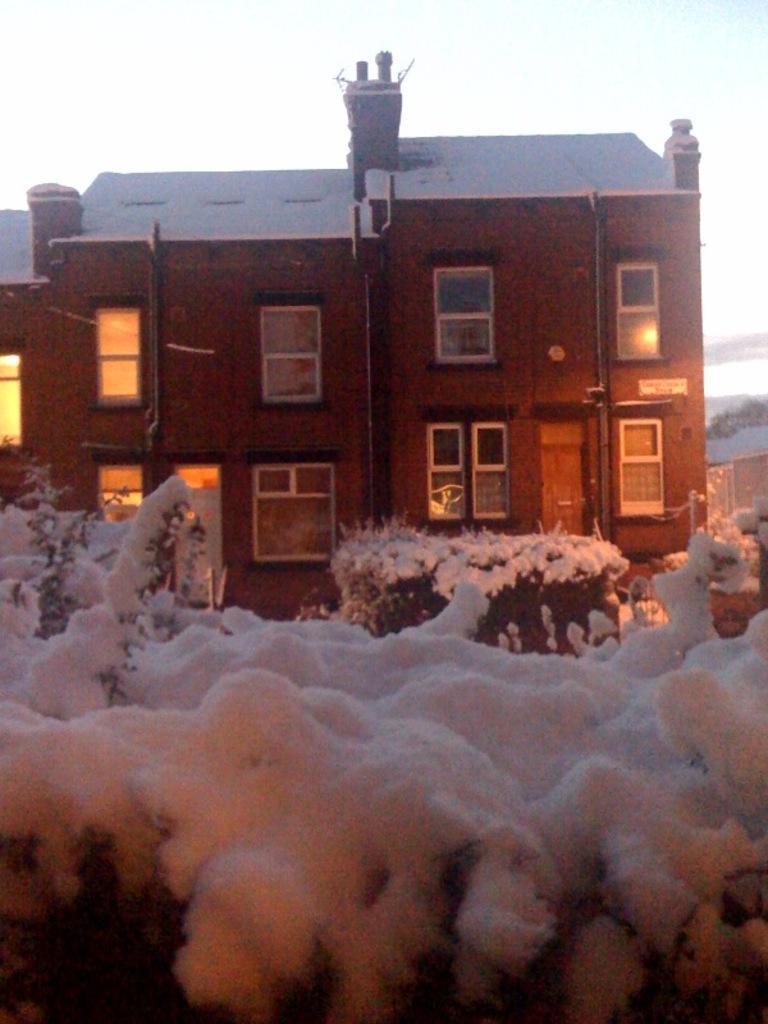Describe this image in one or two sentences. In this picture there is a building in the center, on which there are windows in the image and there are plants at the bottom side of the image and there is snow on the plants and on the building. 